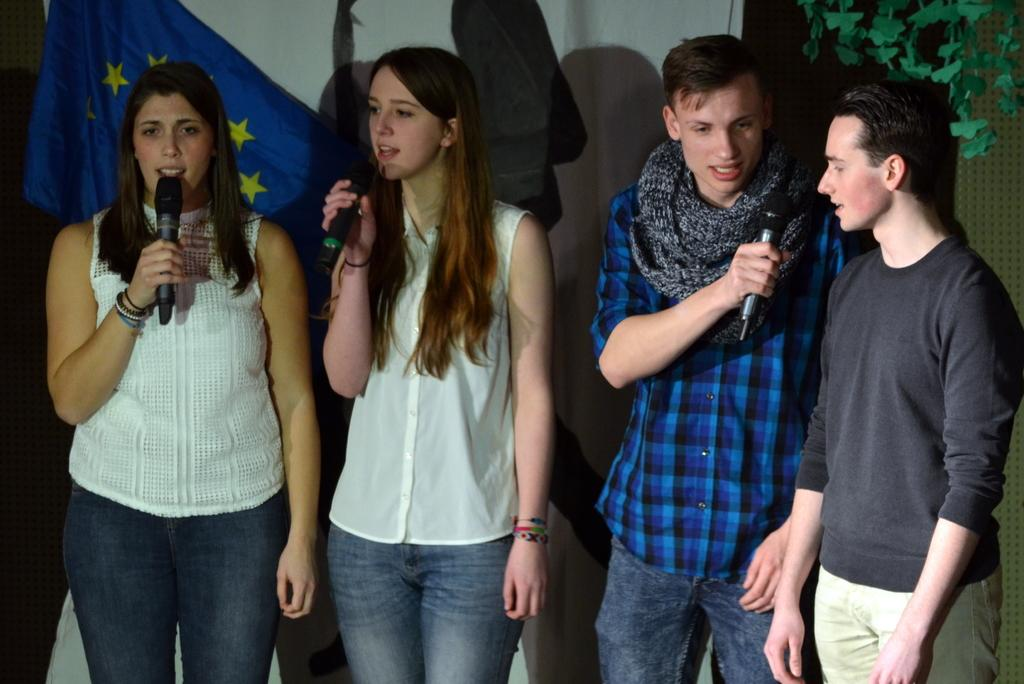How many people are present in the image? There are four people in the image. What can be observed about the clothing of the people in the image? The people are wearing different color dresses. What are the people holding in the image? There are people holding microphones in the image. What can be seen in the background of the image? There is a flag, a wall, and decorative plants in the background of the image. What type of potato is being harvested on the farm in the image? There is no potato or farm present in the image. 